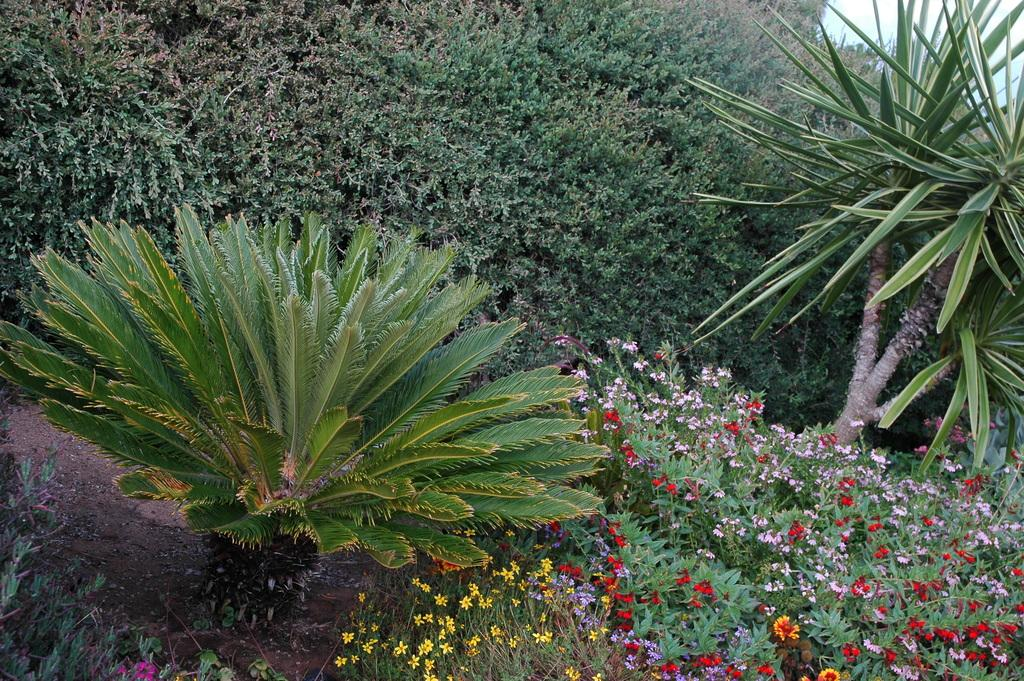What type of plants are at the bottom side of the image? There are flower plants at the bottom side of the image. What can be observed in the surrounding area of the image? There is greenery around the area of the image. How does the toe of the bird feel in the image? There are no birds or toes present in the image, so it is not possible to determine how a bird's toe might feel. 